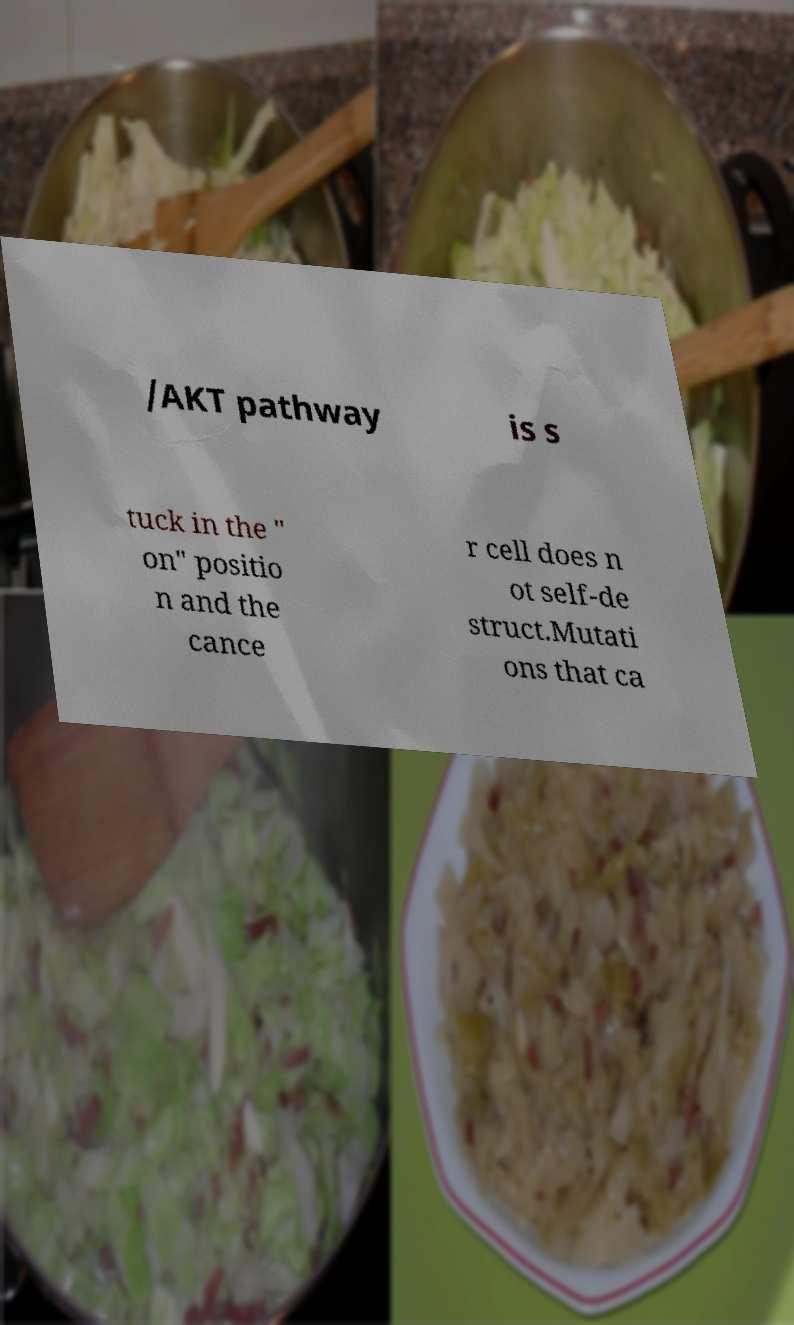I need the written content from this picture converted into text. Can you do that? /AKT pathway is s tuck in the " on" positio n and the cance r cell does n ot self-de struct.Mutati ons that ca 